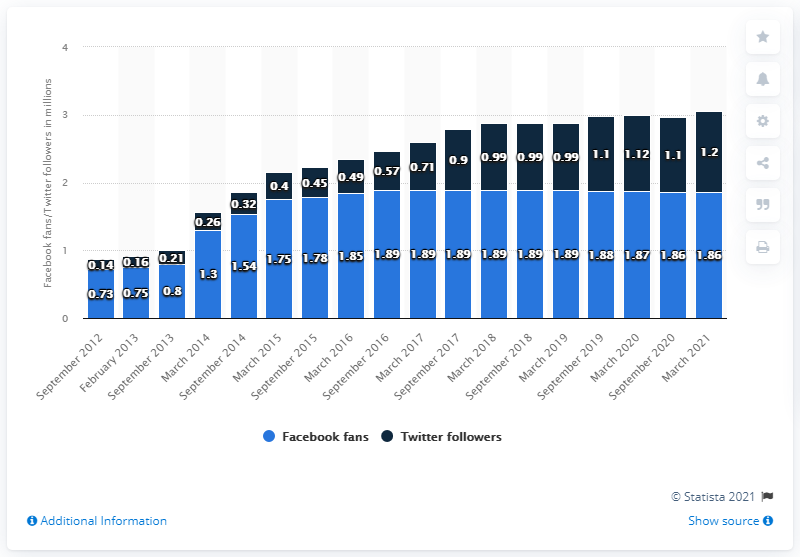List a handful of essential elements in this visual. In March 2021, the Phoenix Suns had 1.86 million Facebook followers. The Phoenix Suns had their Facebook page last updated in September 2012, which was over 9 years ago. The Facebook page of the Phoenix Suns reached 1.86 million in March 2021. 